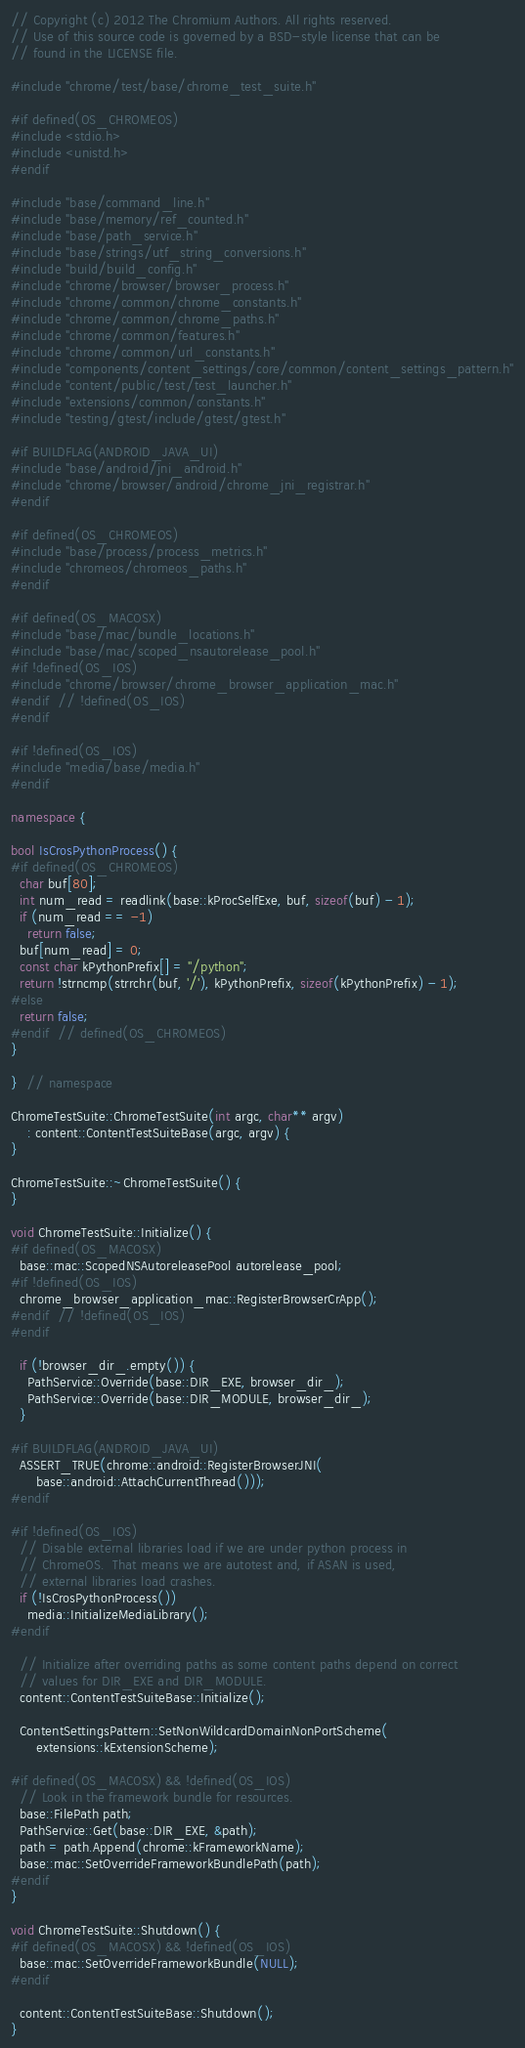Convert code to text. <code><loc_0><loc_0><loc_500><loc_500><_C++_>// Copyright (c) 2012 The Chromium Authors. All rights reserved.
// Use of this source code is governed by a BSD-style license that can be
// found in the LICENSE file.

#include "chrome/test/base/chrome_test_suite.h"

#if defined(OS_CHROMEOS)
#include <stdio.h>
#include <unistd.h>
#endif

#include "base/command_line.h"
#include "base/memory/ref_counted.h"
#include "base/path_service.h"
#include "base/strings/utf_string_conversions.h"
#include "build/build_config.h"
#include "chrome/browser/browser_process.h"
#include "chrome/common/chrome_constants.h"
#include "chrome/common/chrome_paths.h"
#include "chrome/common/features.h"
#include "chrome/common/url_constants.h"
#include "components/content_settings/core/common/content_settings_pattern.h"
#include "content/public/test/test_launcher.h"
#include "extensions/common/constants.h"
#include "testing/gtest/include/gtest/gtest.h"

#if BUILDFLAG(ANDROID_JAVA_UI)
#include "base/android/jni_android.h"
#include "chrome/browser/android/chrome_jni_registrar.h"
#endif

#if defined(OS_CHROMEOS)
#include "base/process/process_metrics.h"
#include "chromeos/chromeos_paths.h"
#endif

#if defined(OS_MACOSX)
#include "base/mac/bundle_locations.h"
#include "base/mac/scoped_nsautorelease_pool.h"
#if !defined(OS_IOS)
#include "chrome/browser/chrome_browser_application_mac.h"
#endif  // !defined(OS_IOS)
#endif

#if !defined(OS_IOS)
#include "media/base/media.h"
#endif

namespace {

bool IsCrosPythonProcess() {
#if defined(OS_CHROMEOS)
  char buf[80];
  int num_read = readlink(base::kProcSelfExe, buf, sizeof(buf) - 1);
  if (num_read == -1)
    return false;
  buf[num_read] = 0;
  const char kPythonPrefix[] = "/python";
  return !strncmp(strrchr(buf, '/'), kPythonPrefix, sizeof(kPythonPrefix) - 1);
#else
  return false;
#endif  // defined(OS_CHROMEOS)
}

}  // namespace

ChromeTestSuite::ChromeTestSuite(int argc, char** argv)
    : content::ContentTestSuiteBase(argc, argv) {
}

ChromeTestSuite::~ChromeTestSuite() {
}

void ChromeTestSuite::Initialize() {
#if defined(OS_MACOSX)
  base::mac::ScopedNSAutoreleasePool autorelease_pool;
#if !defined(OS_IOS)
  chrome_browser_application_mac::RegisterBrowserCrApp();
#endif  // !defined(OS_IOS)
#endif

  if (!browser_dir_.empty()) {
    PathService::Override(base::DIR_EXE, browser_dir_);
    PathService::Override(base::DIR_MODULE, browser_dir_);
  }

#if BUILDFLAG(ANDROID_JAVA_UI)
  ASSERT_TRUE(chrome::android::RegisterBrowserJNI(
      base::android::AttachCurrentThread()));
#endif

#if !defined(OS_IOS)
  // Disable external libraries load if we are under python process in
  // ChromeOS.  That means we are autotest and, if ASAN is used,
  // external libraries load crashes.
  if (!IsCrosPythonProcess())
    media::InitializeMediaLibrary();
#endif

  // Initialize after overriding paths as some content paths depend on correct
  // values for DIR_EXE and DIR_MODULE.
  content::ContentTestSuiteBase::Initialize();

  ContentSettingsPattern::SetNonWildcardDomainNonPortScheme(
      extensions::kExtensionScheme);

#if defined(OS_MACOSX) && !defined(OS_IOS)
  // Look in the framework bundle for resources.
  base::FilePath path;
  PathService::Get(base::DIR_EXE, &path);
  path = path.Append(chrome::kFrameworkName);
  base::mac::SetOverrideFrameworkBundlePath(path);
#endif
}

void ChromeTestSuite::Shutdown() {
#if defined(OS_MACOSX) && !defined(OS_IOS)
  base::mac::SetOverrideFrameworkBundle(NULL);
#endif

  content::ContentTestSuiteBase::Shutdown();
}
</code> 